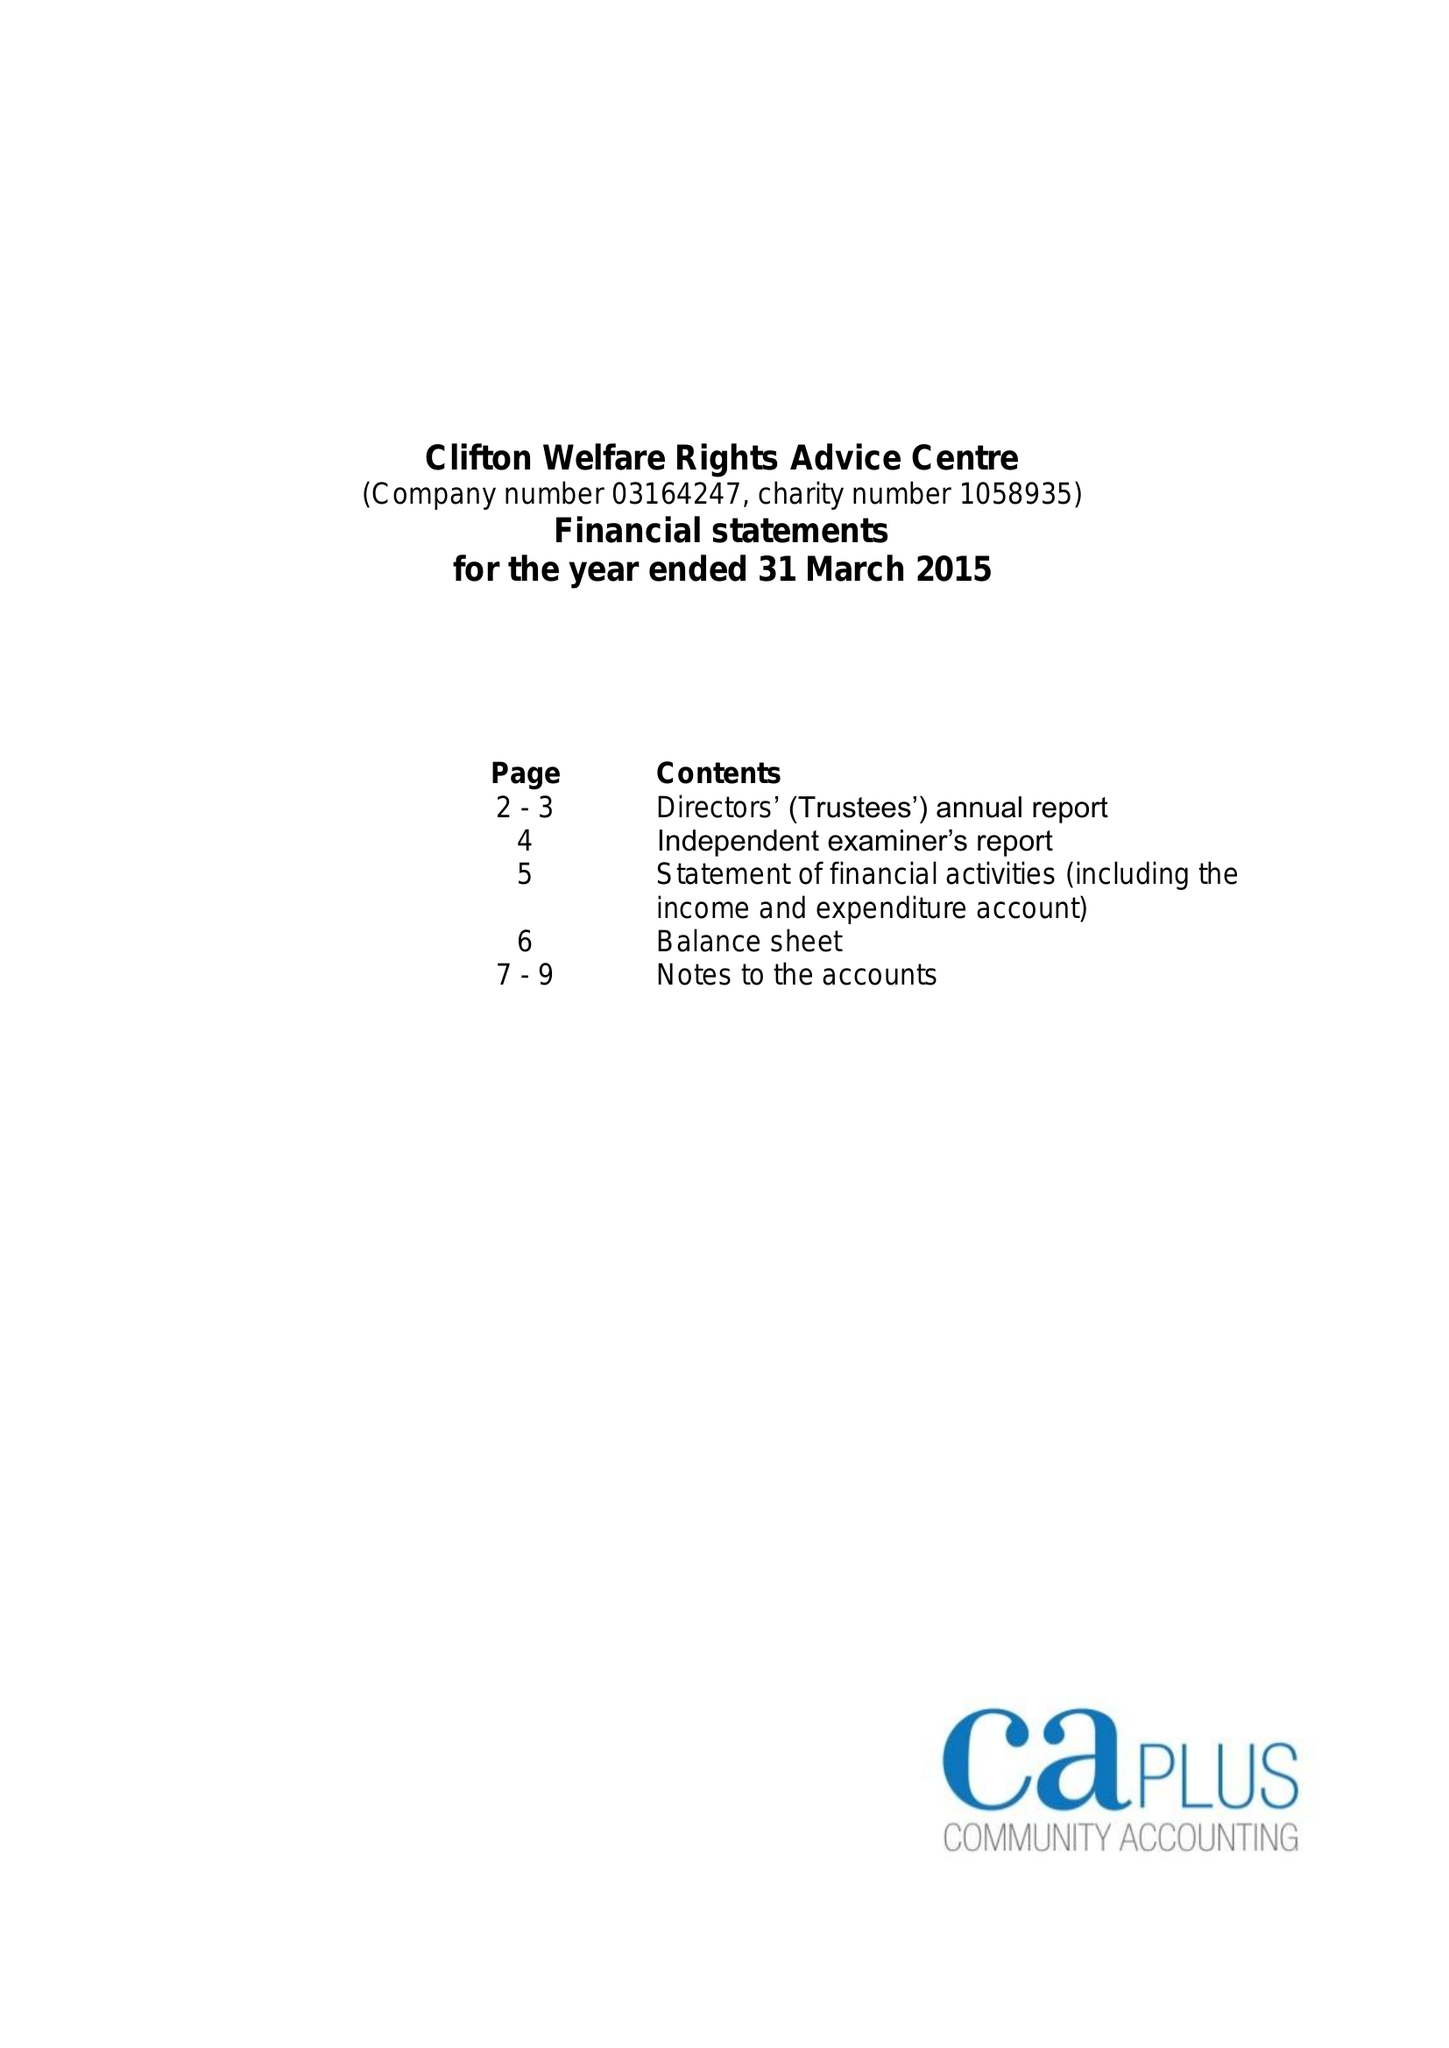What is the value for the spending_annually_in_british_pounds?
Answer the question using a single word or phrase. 62719.00 